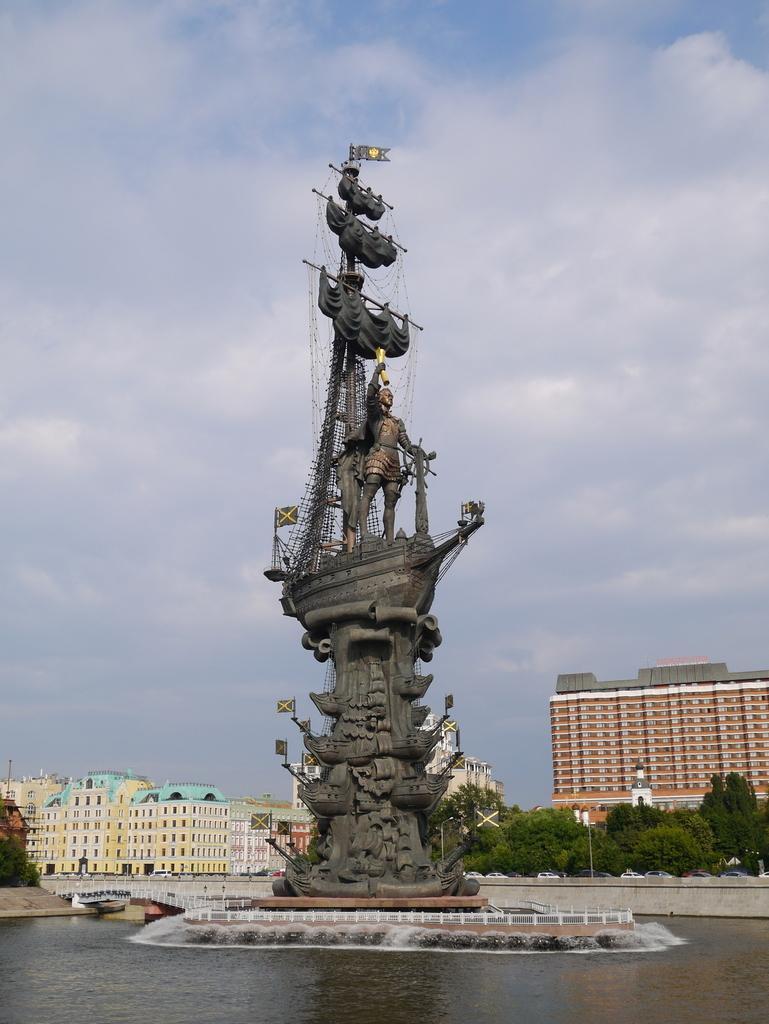Describe this image in one or two sentences. In this picture I can see the statue. I can see the water. I can see the buildings. I can see trees. I can see the bridge. I can see clouds in the sky. 